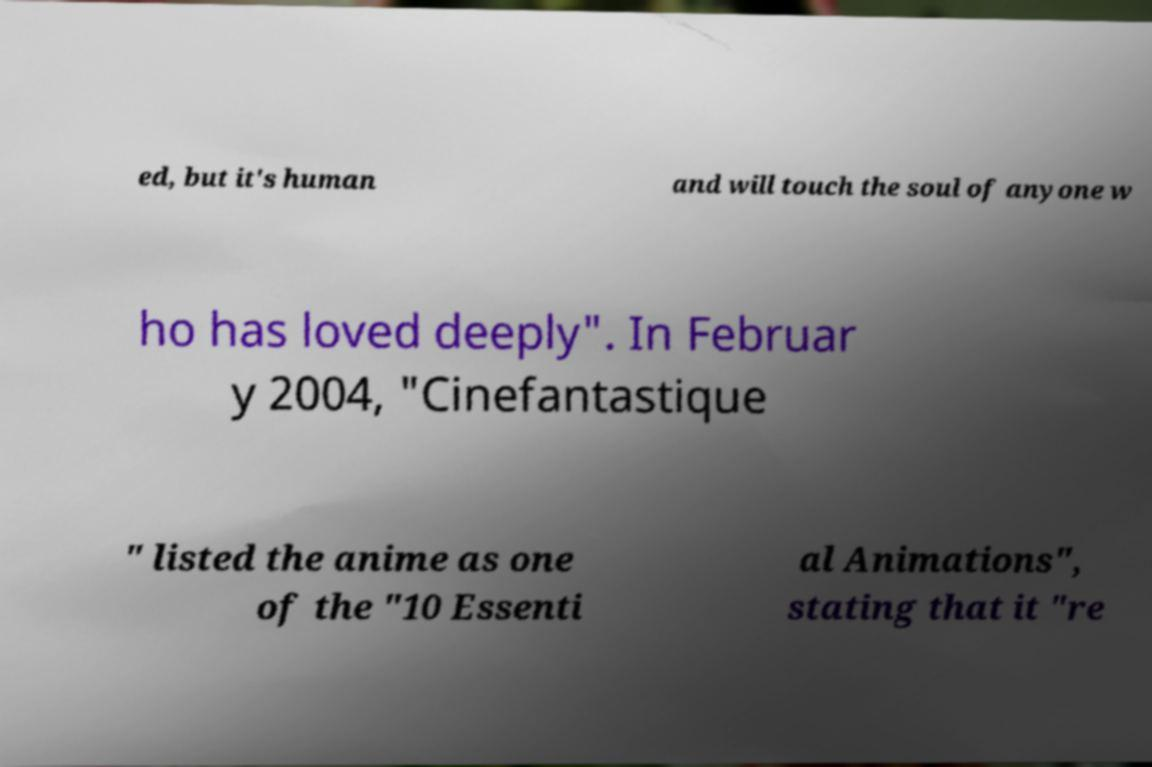Can you accurately transcribe the text from the provided image for me? ed, but it's human and will touch the soul of anyone w ho has loved deeply". In Februar y 2004, "Cinefantastique " listed the anime as one of the "10 Essenti al Animations", stating that it "re 